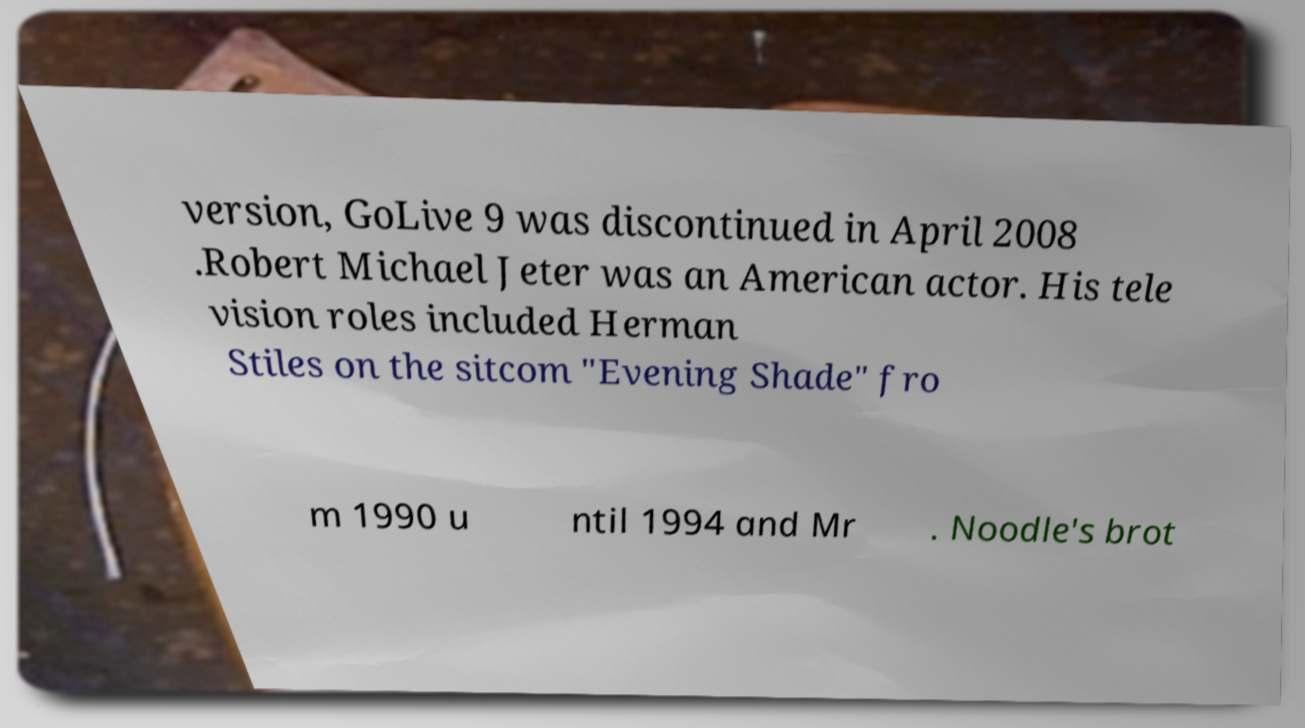Can you accurately transcribe the text from the provided image for me? version, GoLive 9 was discontinued in April 2008 .Robert Michael Jeter was an American actor. His tele vision roles included Herman Stiles on the sitcom "Evening Shade" fro m 1990 u ntil 1994 and Mr . Noodle's brot 